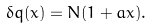Convert formula to latex. <formula><loc_0><loc_0><loc_500><loc_500>\delta q ( x ) = N ( 1 + a x ) .</formula> 